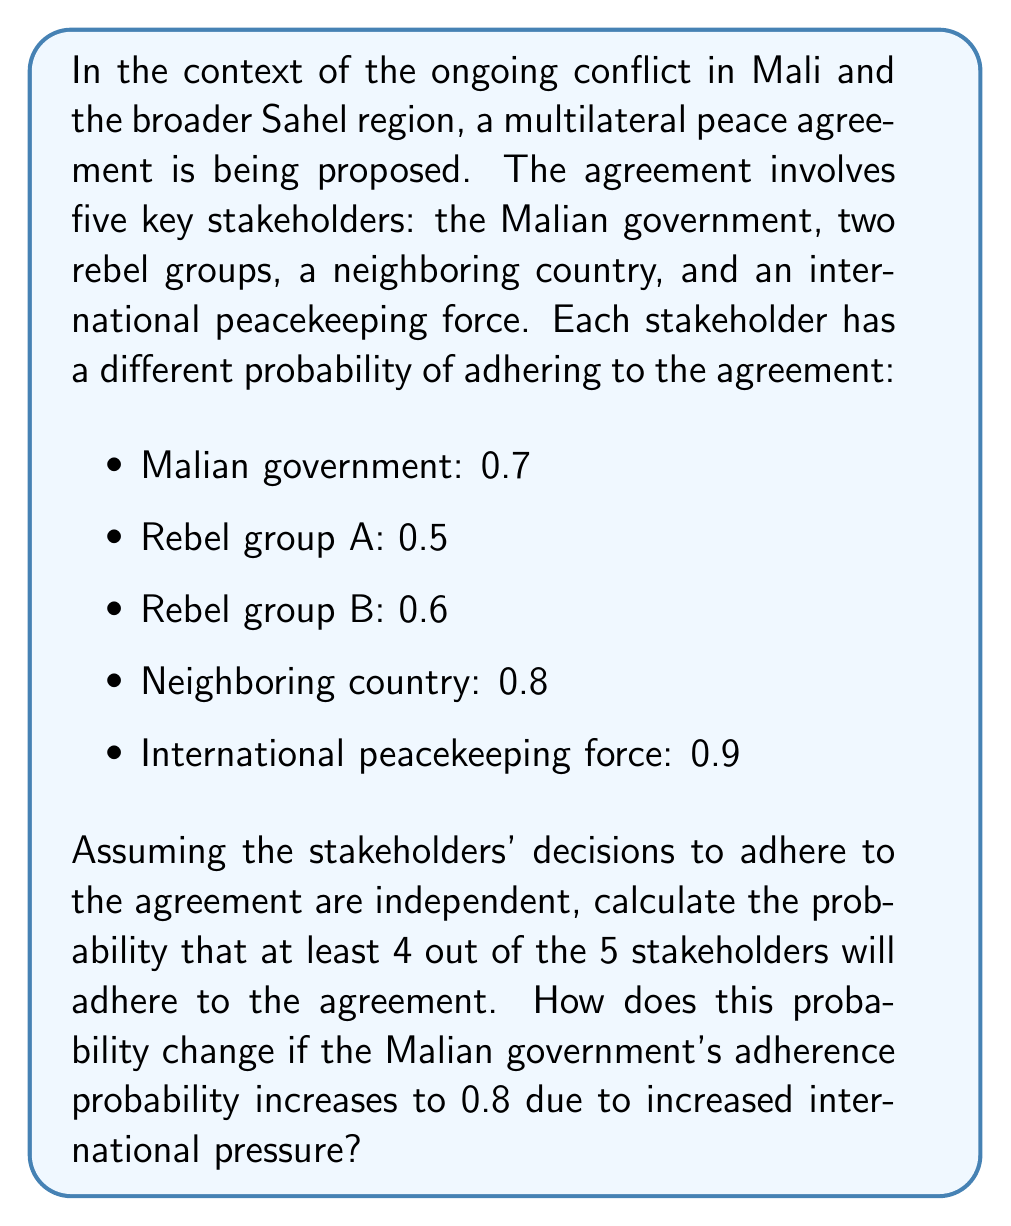Solve this math problem. To solve this problem, we'll use probability theory, specifically the concept of binomial probability.

Step 1: Calculate the probability of exactly 4 stakeholders adhering to the agreement.
Let $p(x)$ be the probability of $x$ stakeholders adhering to the agreement.

$$p(4) = \binom{5}{4}(0.7 \cdot 0.5 \cdot 0.6 \cdot 0.8 \cdot 0.9)(1-0.7)(1-0.5)(1-0.6)(1-0.8)(1-0.9)$$
$$p(4) = 5(0.1512)(0.3 + 0.5 + 0.4 + 0.2 + 0.1)$$
$$p(4) = 5(0.1512)(1.5) = 1.134$$

Step 2: Calculate the probability of all 5 stakeholders adhering to the agreement.
$$p(5) = 0.7 \cdot 0.5 \cdot 0.6 \cdot 0.8 \cdot 0.9 = 0.1512$$

Step 3: Calculate the probability of at least 4 stakeholders adhering to the agreement.
$$P(\text{at least 4}) = p(4) + p(5) = 1.134 + 0.1512 = 0.2646$$

Step 4: Recalculate with the Malian government's probability increased to 0.8.
$$p'(4) = 5(0.1728)(0.2 + 0.5 + 0.4 + 0.2 + 0.1) = 1.2096$$
$$p'(5) = 0.8 \cdot 0.5 \cdot 0.6 \cdot 0.8 \cdot 0.9 = 0.1728$$
$$P'(\text{at least 4}) = p'(4) + p'(5) = 1.2096 + 0.1728 = 0.3824$$

The change in probability is:
$$\Delta P = 0.3824 - 0.2646 = 0.1178$$
Answer: The probability that at least 4 out of 5 stakeholders will adhere to the agreement is 0.2646 or 26.46%. When the Malian government's adherence probability increases to 0.8, this probability increases to 0.3824 or 38.24%, a change of 0.1178 or 11.78 percentage points. 